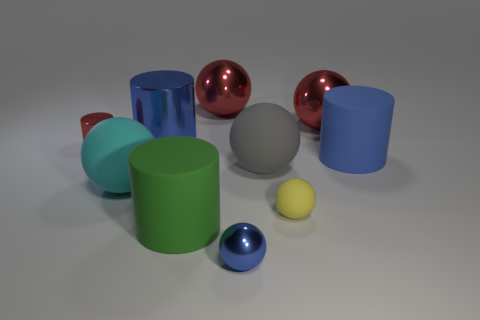Can you describe the lighting of the scene? The lighting in the scene appears to be coming from the upper left side, as indicated by the shadows cast towards the right and slightly downward. It is soft and diffused, suggesting an indirect light source. 